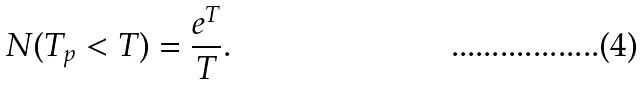<formula> <loc_0><loc_0><loc_500><loc_500>N ( T _ { p } < T ) = \frac { e ^ { T } } { T } .</formula> 